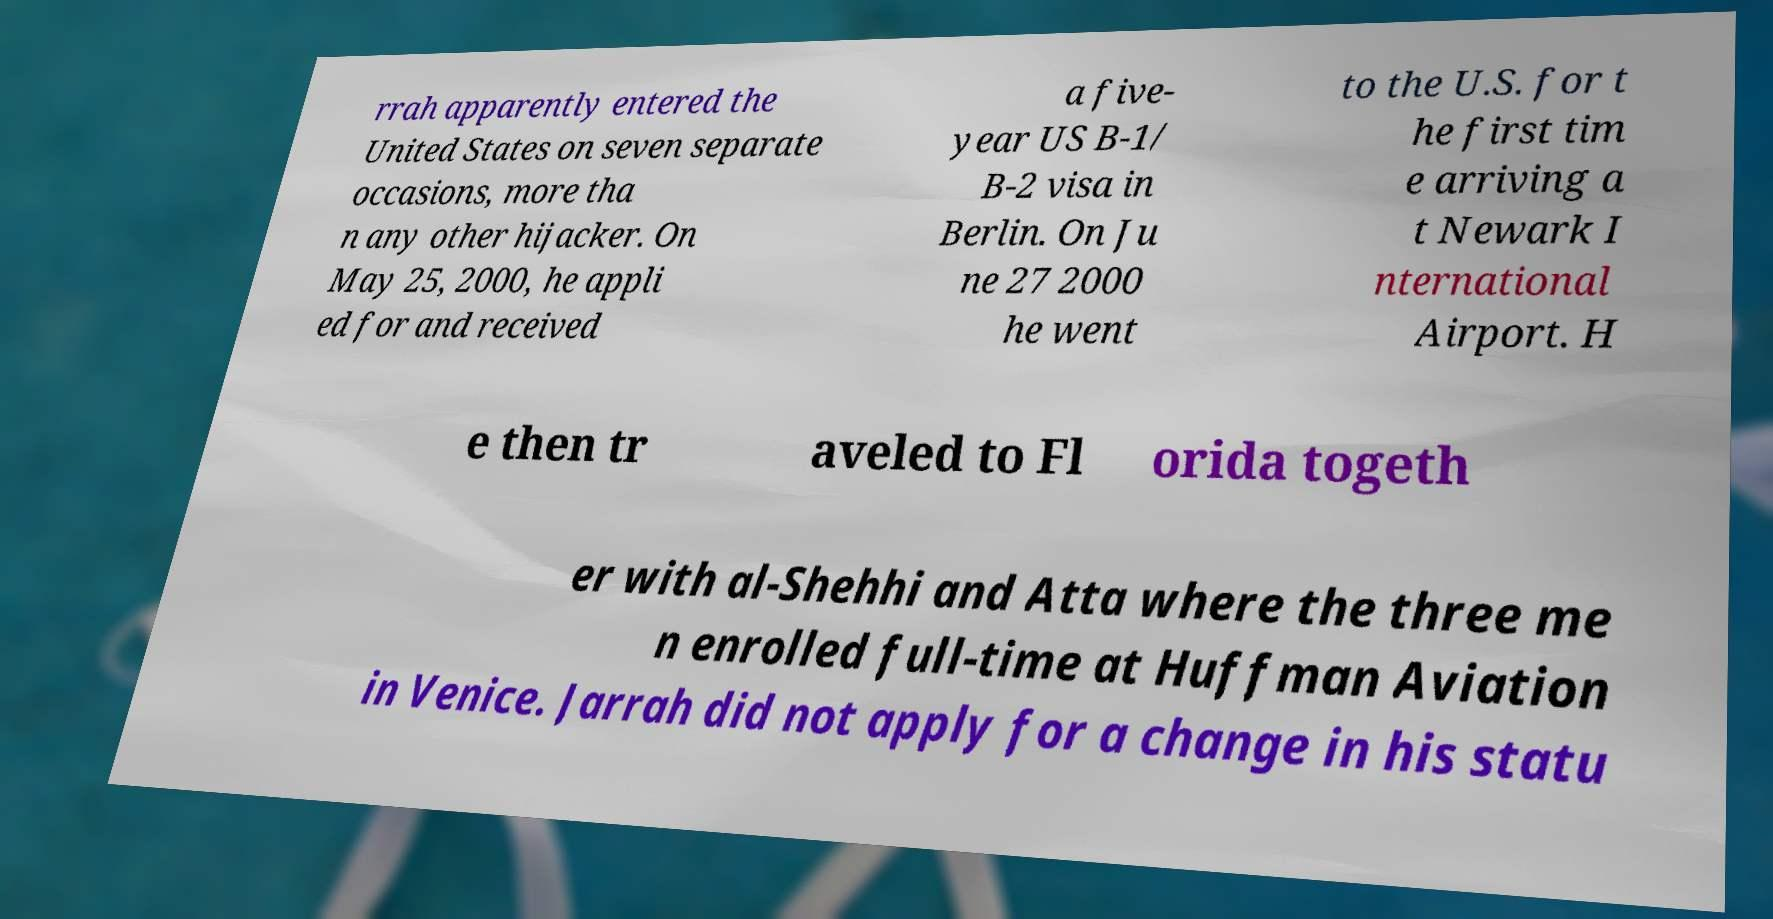Please read and relay the text visible in this image. What does it say? rrah apparently entered the United States on seven separate occasions, more tha n any other hijacker. On May 25, 2000, he appli ed for and received a five- year US B-1/ B-2 visa in Berlin. On Ju ne 27 2000 he went to the U.S. for t he first tim e arriving a t Newark I nternational Airport. H e then tr aveled to Fl orida togeth er with al-Shehhi and Atta where the three me n enrolled full-time at Huffman Aviation in Venice. Jarrah did not apply for a change in his statu 